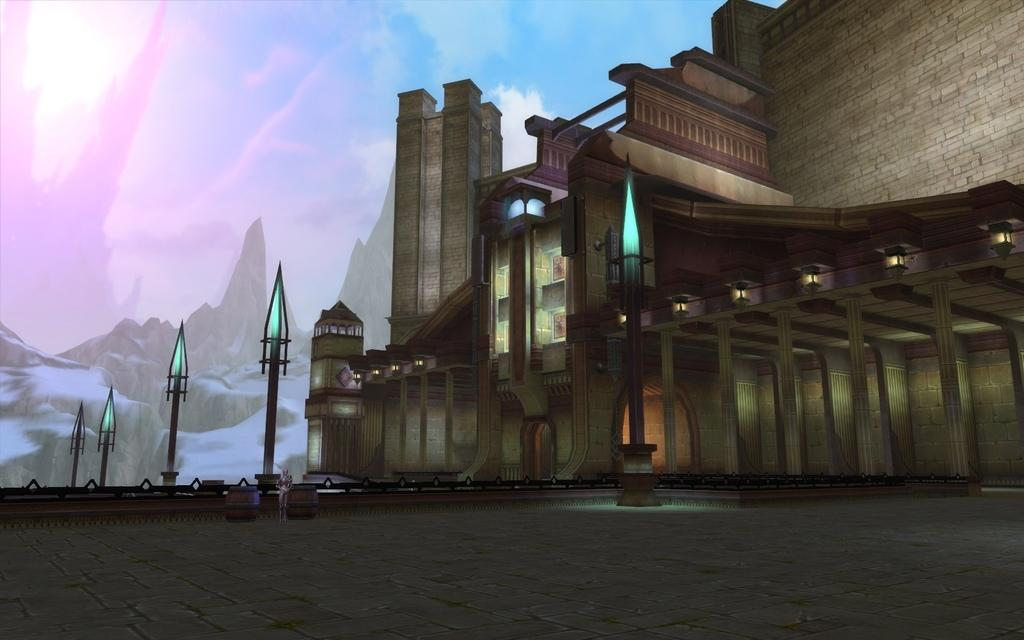What type of structures can be seen in the image? There are buildings in the image. What are the vertical supports in the image? There are poles in the image. What are the sources of illumination in the image? There are lights in the image. What architectural elements can be seen in the image? There are pillars in the image. What surface is visible in the image? There is a floor in the image. What natural features can be seen in the image? There are mountains in the image. What is visible above the structures and mountains in the image? There is sky visible in the image. What atmospheric elements can be seen in the sky? There are clouds in the image. How many cows are grazing on the floor in the image? There are no cows present in the image. What type of visitor can be seen interacting with the pillars in the image? There are no visitors present in the image. 